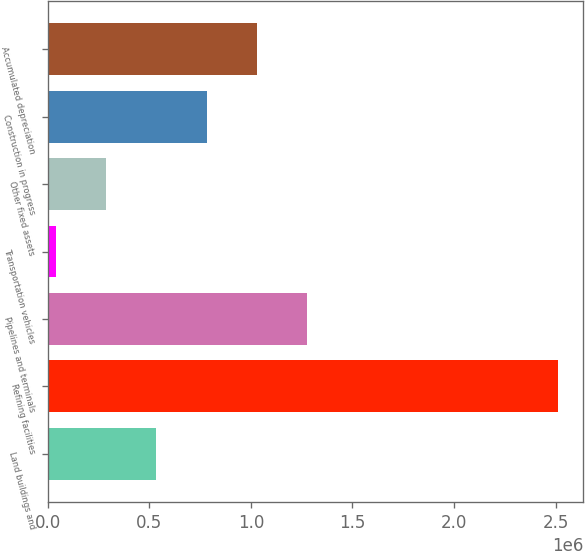Convert chart to OTSL. <chart><loc_0><loc_0><loc_500><loc_500><bar_chart><fcel>Land buildings and<fcel>Refining facilities<fcel>Pipelines and terminals<fcel>Transportation vehicles<fcel>Other fixed assets<fcel>Construction in progress<fcel>Accumulated depreciation<nl><fcel>535003<fcel>2.51075e+06<fcel>1.27591e+06<fcel>41066<fcel>288034<fcel>781971<fcel>1.02894e+06<nl></chart> 